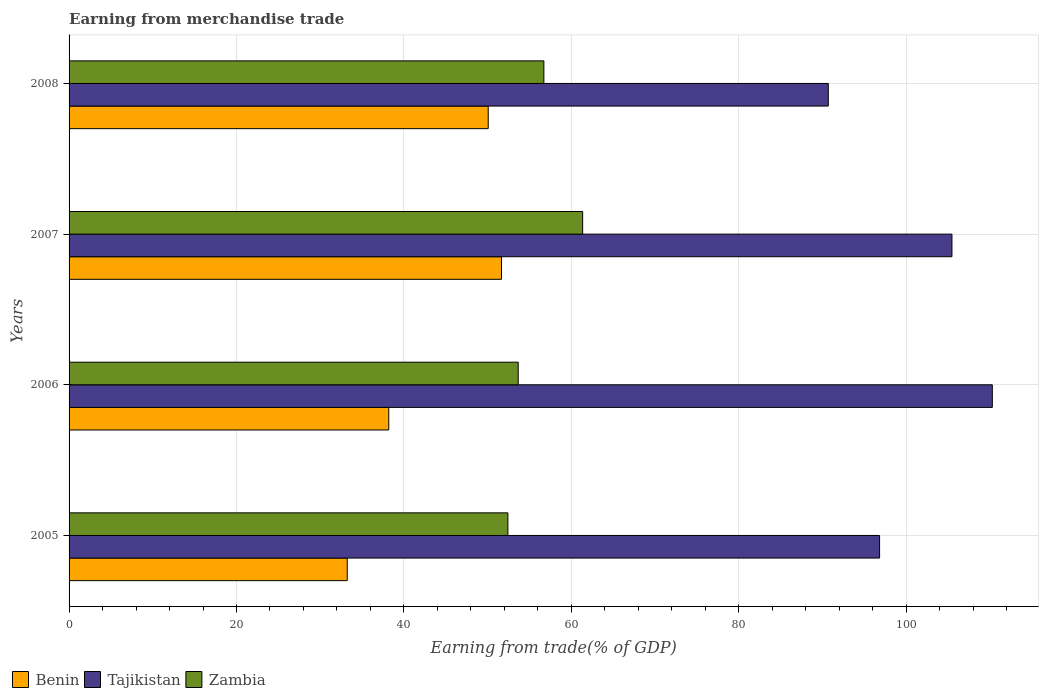How many different coloured bars are there?
Offer a very short reply. 3. How many groups of bars are there?
Offer a terse response. 4. Are the number of bars per tick equal to the number of legend labels?
Give a very brief answer. Yes. Are the number of bars on each tick of the Y-axis equal?
Make the answer very short. Yes. What is the label of the 1st group of bars from the top?
Your answer should be very brief. 2008. In how many cases, is the number of bars for a given year not equal to the number of legend labels?
Your response must be concise. 0. What is the earnings from trade in Tajikistan in 2005?
Your answer should be compact. 96.83. Across all years, what is the maximum earnings from trade in Benin?
Keep it short and to the point. 51.66. Across all years, what is the minimum earnings from trade in Zambia?
Keep it short and to the point. 52.42. In which year was the earnings from trade in Tajikistan maximum?
Provide a short and direct response. 2006. In which year was the earnings from trade in Tajikistan minimum?
Your answer should be compact. 2008. What is the total earnings from trade in Zambia in the graph?
Provide a short and direct response. 224.15. What is the difference between the earnings from trade in Zambia in 2006 and that in 2007?
Your answer should be very brief. -7.7. What is the difference between the earnings from trade in Zambia in 2006 and the earnings from trade in Tajikistan in 2007?
Your answer should be very brief. -51.82. What is the average earnings from trade in Tajikistan per year?
Give a very brief answer. 100.82. In the year 2005, what is the difference between the earnings from trade in Zambia and earnings from trade in Tajikistan?
Make the answer very short. -44.41. In how many years, is the earnings from trade in Zambia greater than 8 %?
Provide a short and direct response. 4. What is the ratio of the earnings from trade in Benin in 2005 to that in 2008?
Offer a very short reply. 0.66. What is the difference between the highest and the second highest earnings from trade in Tajikistan?
Provide a succinct answer. 4.82. What is the difference between the highest and the lowest earnings from trade in Benin?
Your response must be concise. 18.43. In how many years, is the earnings from trade in Zambia greater than the average earnings from trade in Zambia taken over all years?
Keep it short and to the point. 2. Is the sum of the earnings from trade in Zambia in 2006 and 2008 greater than the maximum earnings from trade in Tajikistan across all years?
Your response must be concise. Yes. What does the 3rd bar from the top in 2005 represents?
Give a very brief answer. Benin. What does the 2nd bar from the bottom in 2007 represents?
Your answer should be compact. Tajikistan. Are all the bars in the graph horizontal?
Your response must be concise. Yes. How many years are there in the graph?
Make the answer very short. 4. What is the difference between two consecutive major ticks on the X-axis?
Provide a succinct answer. 20. Are the values on the major ticks of X-axis written in scientific E-notation?
Provide a succinct answer. No. Does the graph contain any zero values?
Your answer should be compact. No. Where does the legend appear in the graph?
Provide a short and direct response. Bottom left. How are the legend labels stacked?
Keep it short and to the point. Horizontal. What is the title of the graph?
Make the answer very short. Earning from merchandise trade. Does "Morocco" appear as one of the legend labels in the graph?
Provide a short and direct response. No. What is the label or title of the X-axis?
Provide a succinct answer. Earning from trade(% of GDP). What is the Earning from trade(% of GDP) in Benin in 2005?
Your answer should be very brief. 33.23. What is the Earning from trade(% of GDP) of Tajikistan in 2005?
Offer a terse response. 96.83. What is the Earning from trade(% of GDP) in Zambia in 2005?
Your answer should be compact. 52.42. What is the Earning from trade(% of GDP) of Benin in 2006?
Your answer should be compact. 38.19. What is the Earning from trade(% of GDP) in Tajikistan in 2006?
Provide a short and direct response. 110.29. What is the Earning from trade(% of GDP) of Zambia in 2006?
Provide a short and direct response. 53.65. What is the Earning from trade(% of GDP) of Benin in 2007?
Your response must be concise. 51.66. What is the Earning from trade(% of GDP) of Tajikistan in 2007?
Your answer should be very brief. 105.47. What is the Earning from trade(% of GDP) in Zambia in 2007?
Offer a terse response. 61.35. What is the Earning from trade(% of GDP) of Benin in 2008?
Offer a very short reply. 50.07. What is the Earning from trade(% of GDP) in Tajikistan in 2008?
Give a very brief answer. 90.7. What is the Earning from trade(% of GDP) in Zambia in 2008?
Provide a succinct answer. 56.72. Across all years, what is the maximum Earning from trade(% of GDP) of Benin?
Ensure brevity in your answer.  51.66. Across all years, what is the maximum Earning from trade(% of GDP) in Tajikistan?
Give a very brief answer. 110.29. Across all years, what is the maximum Earning from trade(% of GDP) of Zambia?
Make the answer very short. 61.35. Across all years, what is the minimum Earning from trade(% of GDP) in Benin?
Make the answer very short. 33.23. Across all years, what is the minimum Earning from trade(% of GDP) in Tajikistan?
Your answer should be very brief. 90.7. Across all years, what is the minimum Earning from trade(% of GDP) in Zambia?
Keep it short and to the point. 52.42. What is the total Earning from trade(% of GDP) of Benin in the graph?
Offer a terse response. 173.16. What is the total Earning from trade(% of GDP) in Tajikistan in the graph?
Keep it short and to the point. 403.29. What is the total Earning from trade(% of GDP) in Zambia in the graph?
Offer a terse response. 224.15. What is the difference between the Earning from trade(% of GDP) in Benin in 2005 and that in 2006?
Ensure brevity in your answer.  -4.96. What is the difference between the Earning from trade(% of GDP) of Tajikistan in 2005 and that in 2006?
Offer a terse response. -13.47. What is the difference between the Earning from trade(% of GDP) in Zambia in 2005 and that in 2006?
Keep it short and to the point. -1.23. What is the difference between the Earning from trade(% of GDP) of Benin in 2005 and that in 2007?
Keep it short and to the point. -18.43. What is the difference between the Earning from trade(% of GDP) of Tajikistan in 2005 and that in 2007?
Your answer should be very brief. -8.64. What is the difference between the Earning from trade(% of GDP) in Zambia in 2005 and that in 2007?
Your answer should be very brief. -8.93. What is the difference between the Earning from trade(% of GDP) of Benin in 2005 and that in 2008?
Make the answer very short. -16.84. What is the difference between the Earning from trade(% of GDP) in Tajikistan in 2005 and that in 2008?
Your answer should be compact. 6.13. What is the difference between the Earning from trade(% of GDP) in Zambia in 2005 and that in 2008?
Your response must be concise. -4.3. What is the difference between the Earning from trade(% of GDP) in Benin in 2006 and that in 2007?
Your response must be concise. -13.47. What is the difference between the Earning from trade(% of GDP) of Tajikistan in 2006 and that in 2007?
Your answer should be compact. 4.82. What is the difference between the Earning from trade(% of GDP) in Zambia in 2006 and that in 2007?
Your answer should be compact. -7.7. What is the difference between the Earning from trade(% of GDP) in Benin in 2006 and that in 2008?
Your response must be concise. -11.88. What is the difference between the Earning from trade(% of GDP) in Tajikistan in 2006 and that in 2008?
Ensure brevity in your answer.  19.59. What is the difference between the Earning from trade(% of GDP) in Zambia in 2006 and that in 2008?
Your response must be concise. -3.07. What is the difference between the Earning from trade(% of GDP) of Benin in 2007 and that in 2008?
Provide a short and direct response. 1.59. What is the difference between the Earning from trade(% of GDP) of Tajikistan in 2007 and that in 2008?
Your response must be concise. 14.77. What is the difference between the Earning from trade(% of GDP) in Zambia in 2007 and that in 2008?
Keep it short and to the point. 4.63. What is the difference between the Earning from trade(% of GDP) of Benin in 2005 and the Earning from trade(% of GDP) of Tajikistan in 2006?
Ensure brevity in your answer.  -77.07. What is the difference between the Earning from trade(% of GDP) of Benin in 2005 and the Earning from trade(% of GDP) of Zambia in 2006?
Give a very brief answer. -20.43. What is the difference between the Earning from trade(% of GDP) in Tajikistan in 2005 and the Earning from trade(% of GDP) in Zambia in 2006?
Provide a succinct answer. 43.17. What is the difference between the Earning from trade(% of GDP) in Benin in 2005 and the Earning from trade(% of GDP) in Tajikistan in 2007?
Offer a very short reply. -72.24. What is the difference between the Earning from trade(% of GDP) of Benin in 2005 and the Earning from trade(% of GDP) of Zambia in 2007?
Offer a very short reply. -28.12. What is the difference between the Earning from trade(% of GDP) of Tajikistan in 2005 and the Earning from trade(% of GDP) of Zambia in 2007?
Give a very brief answer. 35.47. What is the difference between the Earning from trade(% of GDP) of Benin in 2005 and the Earning from trade(% of GDP) of Tajikistan in 2008?
Offer a very short reply. -57.47. What is the difference between the Earning from trade(% of GDP) in Benin in 2005 and the Earning from trade(% of GDP) in Zambia in 2008?
Provide a succinct answer. -23.49. What is the difference between the Earning from trade(% of GDP) of Tajikistan in 2005 and the Earning from trade(% of GDP) of Zambia in 2008?
Give a very brief answer. 40.11. What is the difference between the Earning from trade(% of GDP) in Benin in 2006 and the Earning from trade(% of GDP) in Tajikistan in 2007?
Keep it short and to the point. -67.28. What is the difference between the Earning from trade(% of GDP) in Benin in 2006 and the Earning from trade(% of GDP) in Zambia in 2007?
Provide a short and direct response. -23.16. What is the difference between the Earning from trade(% of GDP) in Tajikistan in 2006 and the Earning from trade(% of GDP) in Zambia in 2007?
Offer a terse response. 48.94. What is the difference between the Earning from trade(% of GDP) in Benin in 2006 and the Earning from trade(% of GDP) in Tajikistan in 2008?
Your response must be concise. -52.51. What is the difference between the Earning from trade(% of GDP) of Benin in 2006 and the Earning from trade(% of GDP) of Zambia in 2008?
Your answer should be very brief. -18.53. What is the difference between the Earning from trade(% of GDP) in Tajikistan in 2006 and the Earning from trade(% of GDP) in Zambia in 2008?
Offer a very short reply. 53.57. What is the difference between the Earning from trade(% of GDP) in Benin in 2007 and the Earning from trade(% of GDP) in Tajikistan in 2008?
Your answer should be very brief. -39.04. What is the difference between the Earning from trade(% of GDP) of Benin in 2007 and the Earning from trade(% of GDP) of Zambia in 2008?
Make the answer very short. -5.06. What is the difference between the Earning from trade(% of GDP) in Tajikistan in 2007 and the Earning from trade(% of GDP) in Zambia in 2008?
Your response must be concise. 48.75. What is the average Earning from trade(% of GDP) of Benin per year?
Offer a very short reply. 43.29. What is the average Earning from trade(% of GDP) of Tajikistan per year?
Ensure brevity in your answer.  100.82. What is the average Earning from trade(% of GDP) of Zambia per year?
Make the answer very short. 56.04. In the year 2005, what is the difference between the Earning from trade(% of GDP) of Benin and Earning from trade(% of GDP) of Tajikistan?
Provide a short and direct response. -63.6. In the year 2005, what is the difference between the Earning from trade(% of GDP) in Benin and Earning from trade(% of GDP) in Zambia?
Offer a terse response. -19.19. In the year 2005, what is the difference between the Earning from trade(% of GDP) of Tajikistan and Earning from trade(% of GDP) of Zambia?
Give a very brief answer. 44.41. In the year 2006, what is the difference between the Earning from trade(% of GDP) in Benin and Earning from trade(% of GDP) in Tajikistan?
Your response must be concise. -72.1. In the year 2006, what is the difference between the Earning from trade(% of GDP) of Benin and Earning from trade(% of GDP) of Zambia?
Your answer should be compact. -15.46. In the year 2006, what is the difference between the Earning from trade(% of GDP) in Tajikistan and Earning from trade(% of GDP) in Zambia?
Your response must be concise. 56.64. In the year 2007, what is the difference between the Earning from trade(% of GDP) in Benin and Earning from trade(% of GDP) in Tajikistan?
Provide a short and direct response. -53.81. In the year 2007, what is the difference between the Earning from trade(% of GDP) in Benin and Earning from trade(% of GDP) in Zambia?
Offer a terse response. -9.69. In the year 2007, what is the difference between the Earning from trade(% of GDP) of Tajikistan and Earning from trade(% of GDP) of Zambia?
Your answer should be compact. 44.12. In the year 2008, what is the difference between the Earning from trade(% of GDP) of Benin and Earning from trade(% of GDP) of Tajikistan?
Offer a very short reply. -40.63. In the year 2008, what is the difference between the Earning from trade(% of GDP) in Benin and Earning from trade(% of GDP) in Zambia?
Ensure brevity in your answer.  -6.65. In the year 2008, what is the difference between the Earning from trade(% of GDP) of Tajikistan and Earning from trade(% of GDP) of Zambia?
Your answer should be compact. 33.98. What is the ratio of the Earning from trade(% of GDP) of Benin in 2005 to that in 2006?
Your answer should be very brief. 0.87. What is the ratio of the Earning from trade(% of GDP) in Tajikistan in 2005 to that in 2006?
Your answer should be compact. 0.88. What is the ratio of the Earning from trade(% of GDP) in Benin in 2005 to that in 2007?
Your answer should be very brief. 0.64. What is the ratio of the Earning from trade(% of GDP) in Tajikistan in 2005 to that in 2007?
Give a very brief answer. 0.92. What is the ratio of the Earning from trade(% of GDP) of Zambia in 2005 to that in 2007?
Give a very brief answer. 0.85. What is the ratio of the Earning from trade(% of GDP) in Benin in 2005 to that in 2008?
Your answer should be very brief. 0.66. What is the ratio of the Earning from trade(% of GDP) in Tajikistan in 2005 to that in 2008?
Your answer should be very brief. 1.07. What is the ratio of the Earning from trade(% of GDP) in Zambia in 2005 to that in 2008?
Your answer should be compact. 0.92. What is the ratio of the Earning from trade(% of GDP) of Benin in 2006 to that in 2007?
Provide a succinct answer. 0.74. What is the ratio of the Earning from trade(% of GDP) of Tajikistan in 2006 to that in 2007?
Offer a terse response. 1.05. What is the ratio of the Earning from trade(% of GDP) of Zambia in 2006 to that in 2007?
Your answer should be compact. 0.87. What is the ratio of the Earning from trade(% of GDP) of Benin in 2006 to that in 2008?
Give a very brief answer. 0.76. What is the ratio of the Earning from trade(% of GDP) of Tajikistan in 2006 to that in 2008?
Ensure brevity in your answer.  1.22. What is the ratio of the Earning from trade(% of GDP) in Zambia in 2006 to that in 2008?
Make the answer very short. 0.95. What is the ratio of the Earning from trade(% of GDP) of Benin in 2007 to that in 2008?
Give a very brief answer. 1.03. What is the ratio of the Earning from trade(% of GDP) of Tajikistan in 2007 to that in 2008?
Make the answer very short. 1.16. What is the ratio of the Earning from trade(% of GDP) in Zambia in 2007 to that in 2008?
Provide a succinct answer. 1.08. What is the difference between the highest and the second highest Earning from trade(% of GDP) in Benin?
Your answer should be very brief. 1.59. What is the difference between the highest and the second highest Earning from trade(% of GDP) of Tajikistan?
Your answer should be very brief. 4.82. What is the difference between the highest and the second highest Earning from trade(% of GDP) of Zambia?
Give a very brief answer. 4.63. What is the difference between the highest and the lowest Earning from trade(% of GDP) in Benin?
Your response must be concise. 18.43. What is the difference between the highest and the lowest Earning from trade(% of GDP) in Tajikistan?
Your answer should be compact. 19.59. What is the difference between the highest and the lowest Earning from trade(% of GDP) of Zambia?
Your answer should be very brief. 8.93. 